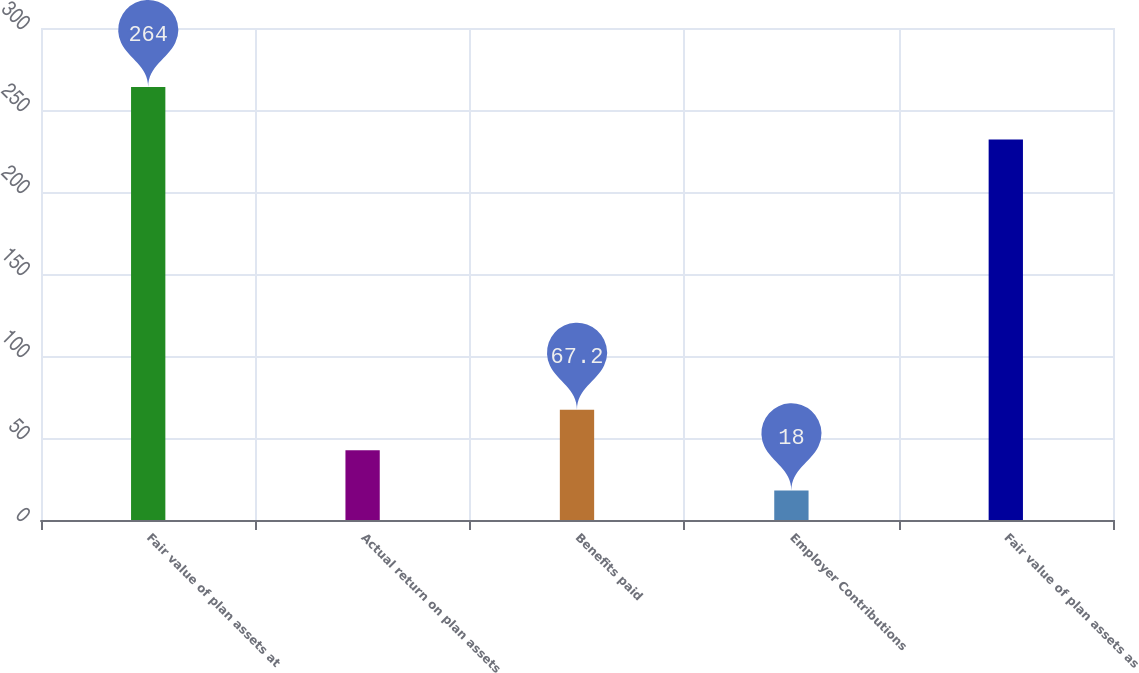<chart> <loc_0><loc_0><loc_500><loc_500><bar_chart><fcel>Fair value of plan assets at<fcel>Actual return on plan assets<fcel>Benefits paid<fcel>Employer Contributions<fcel>Fair value of plan assets as<nl><fcel>264<fcel>42.6<fcel>67.2<fcel>18<fcel>232<nl></chart> 